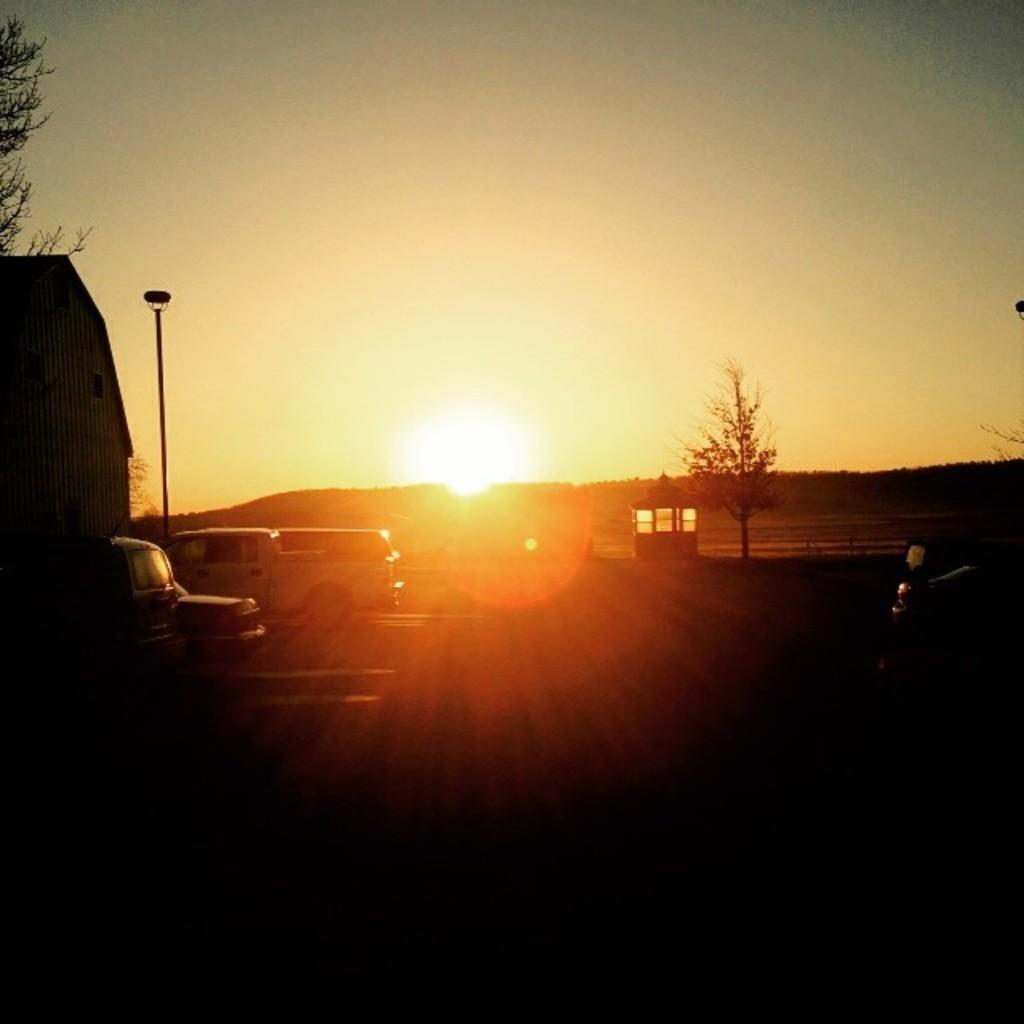What is the nature of the dark part in the image? The image has a dark part, but the specific nature of it cannot be determined from the provided facts. What can be seen moving on the road in the image? There are vehicles moving on the road in the image. What type of house is present in the image? There is a wooden house in the image. What type of vegetation is present in the image? Trees are present in the image. What is visible in the background of the image? The sun and the sky are visible in the background of the image. Can you see any clover growing near the wooden house in the image? There is no mention of clover in the image, so it cannot be determined if any is present. Is there a toad hopping on the road in the image? There is no mention of a toad in the image, so it cannot be determined if one is present. 